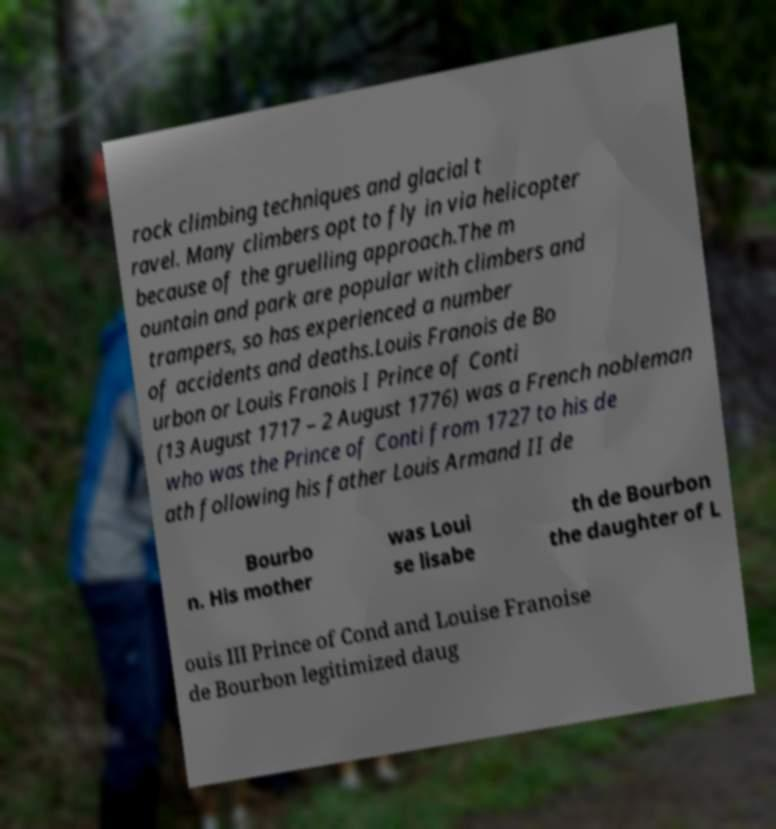Can you accurately transcribe the text from the provided image for me? rock climbing techniques and glacial t ravel. Many climbers opt to fly in via helicopter because of the gruelling approach.The m ountain and park are popular with climbers and trampers, so has experienced a number of accidents and deaths.Louis Franois de Bo urbon or Louis Franois I Prince of Conti (13 August 1717 – 2 August 1776) was a French nobleman who was the Prince of Conti from 1727 to his de ath following his father Louis Armand II de Bourbo n. His mother was Loui se lisabe th de Bourbon the daughter of L ouis III Prince of Cond and Louise Franoise de Bourbon legitimized daug 